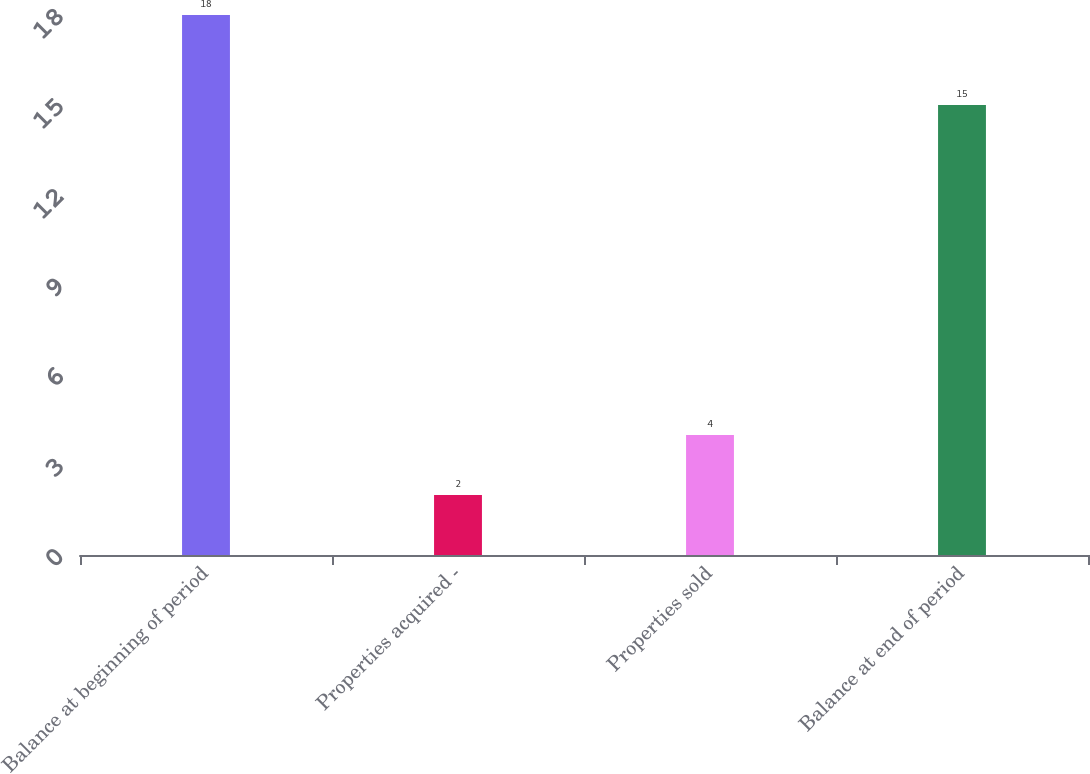Convert chart to OTSL. <chart><loc_0><loc_0><loc_500><loc_500><bar_chart><fcel>Balance at beginning of period<fcel>Properties acquired -<fcel>Properties sold<fcel>Balance at end of period<nl><fcel>18<fcel>2<fcel>4<fcel>15<nl></chart> 